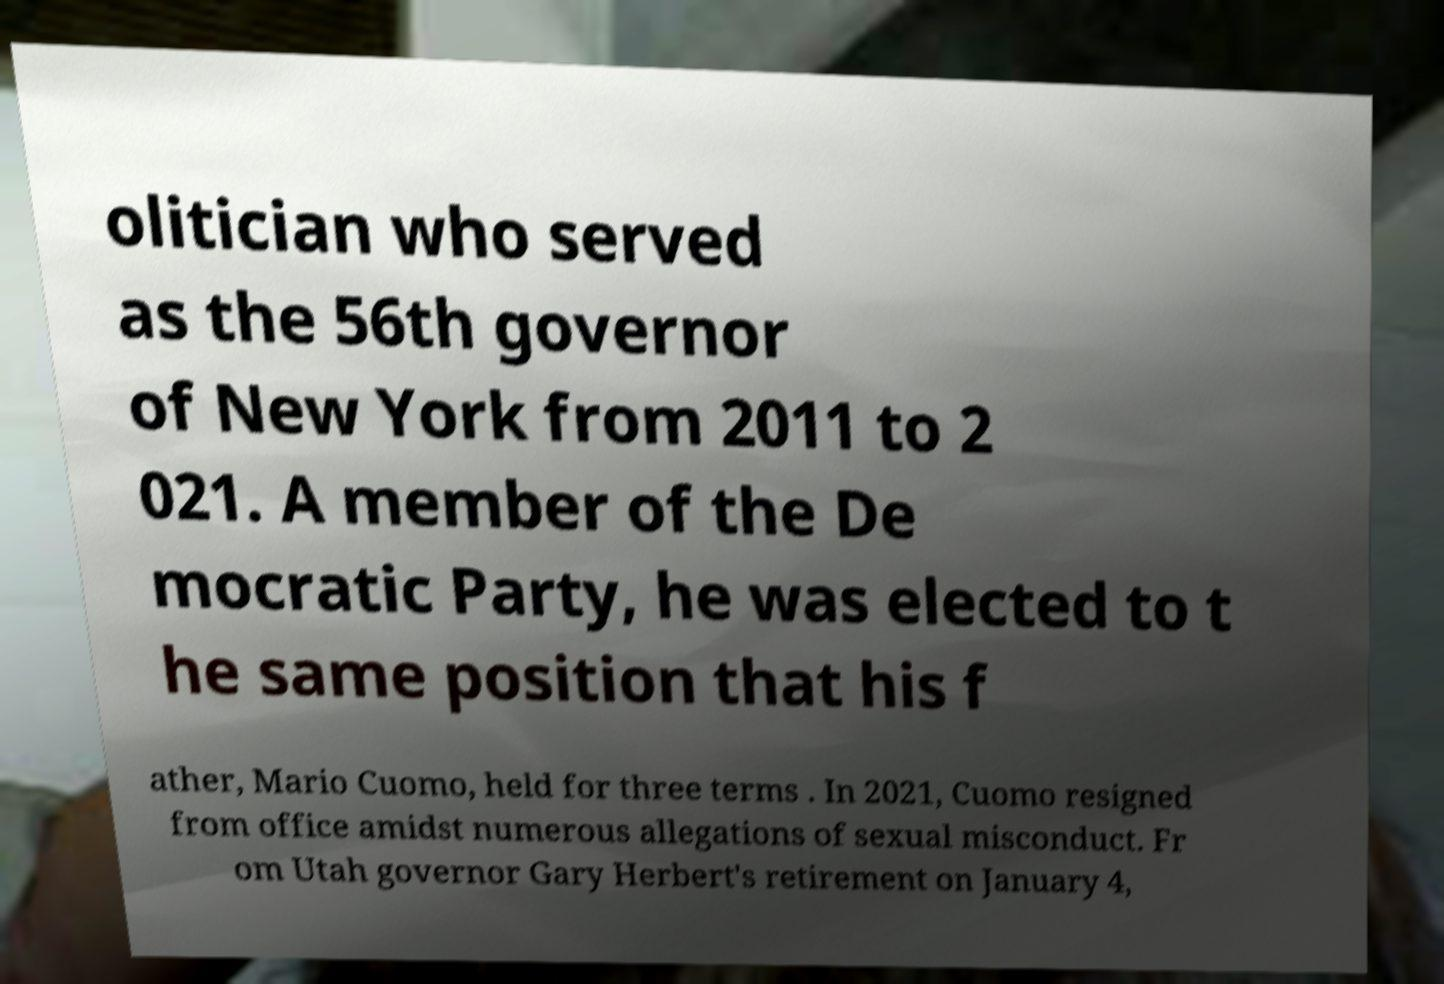What messages or text are displayed in this image? I need them in a readable, typed format. olitician who served as the 56th governor of New York from 2011 to 2 021. A member of the De mocratic Party, he was elected to t he same position that his f ather, Mario Cuomo, held for three terms . In 2021, Cuomo resigned from office amidst numerous allegations of sexual misconduct. Fr om Utah governor Gary Herbert's retirement on January 4, 